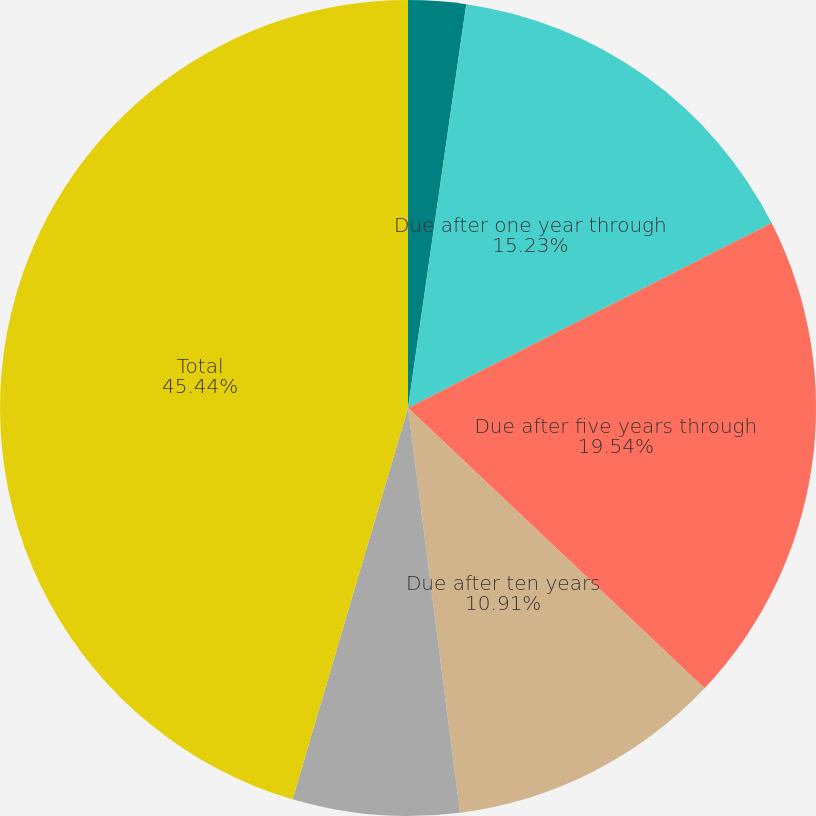Convert chart. <chart><loc_0><loc_0><loc_500><loc_500><pie_chart><fcel>Due in one year or less<fcel>Due after one year through<fcel>Due after five years through<fcel>Due after ten years<fcel>ABS RMBS and CMBS<fcel>Total<nl><fcel>2.28%<fcel>15.23%<fcel>19.54%<fcel>10.91%<fcel>6.6%<fcel>45.43%<nl></chart> 